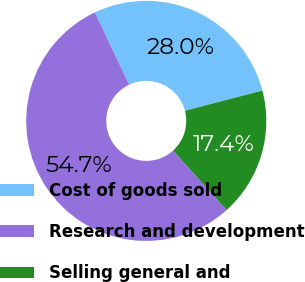Convert chart to OTSL. <chart><loc_0><loc_0><loc_500><loc_500><pie_chart><fcel>Cost of goods sold<fcel>Research and development<fcel>Selling general and<nl><fcel>27.97%<fcel>54.65%<fcel>17.38%<nl></chart> 